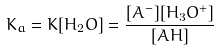<formula> <loc_0><loc_0><loc_500><loc_500>K _ { a } = K [ H _ { 2 } O ] = \frac { [ A ^ { - } ] [ H _ { 3 } O ^ { + } ] } { [ A H ] }</formula> 